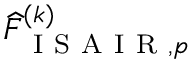<formula> <loc_0><loc_0><loc_500><loc_500>\widehat { F } _ { I S A I R , p } ^ { ( k ) }</formula> 